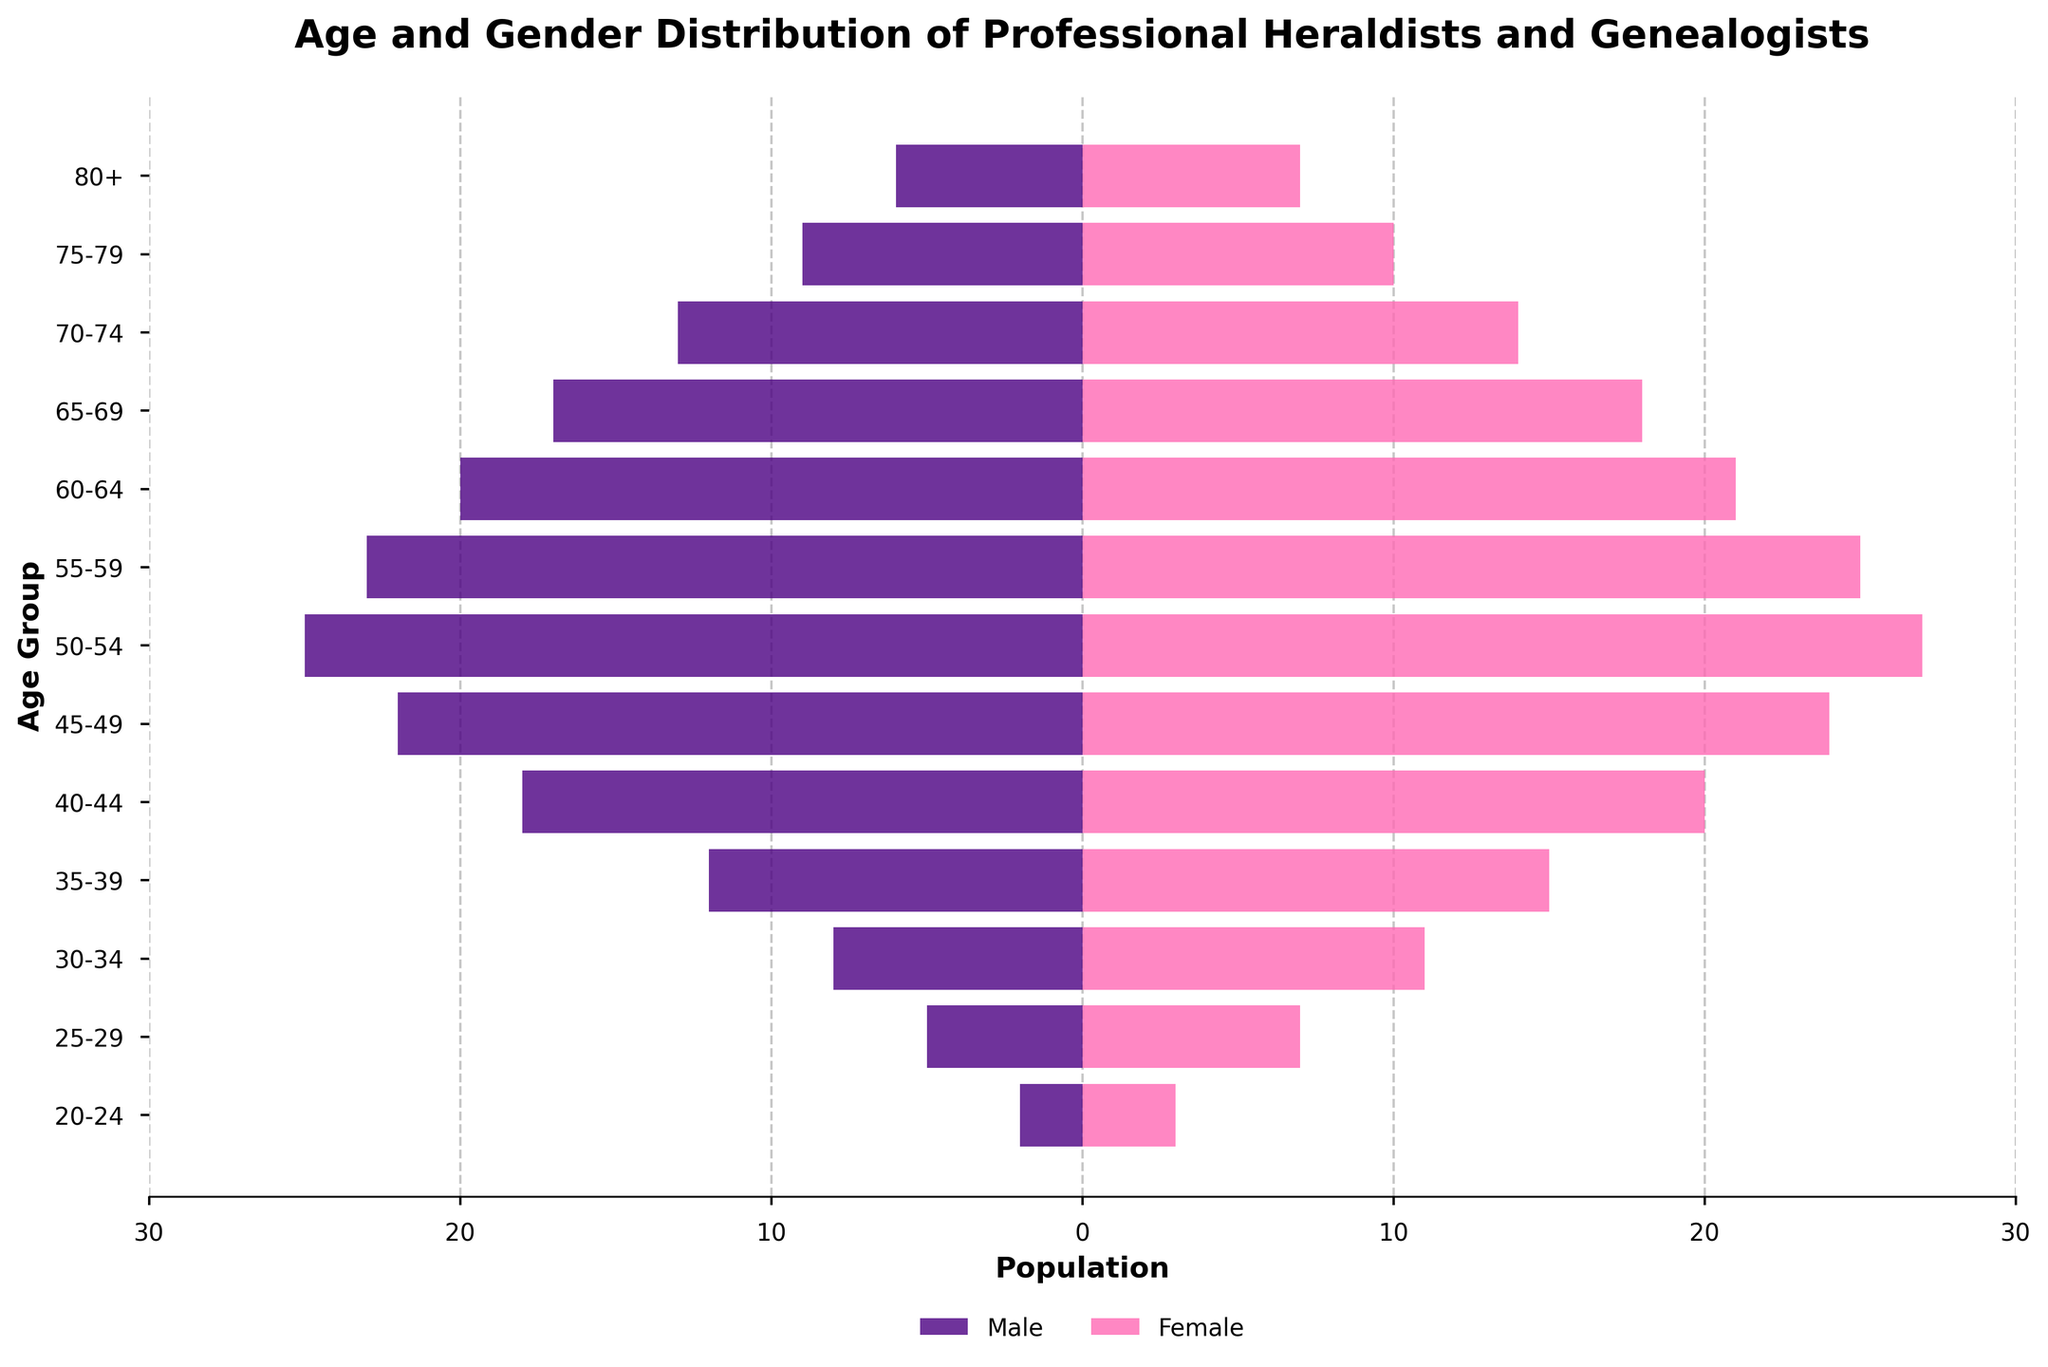What is the title of the figure? The title is found at the top of the figure and is used to describe what the figure represents. Here, it provides an overview of the subject of the distribution being shown.
Answer: Age and Gender Distribution of Professional Heraldists and Genealogists What are the colors used to represent males and females? The colors are distinct and help differentiate between the genders. Males are represented with a dark color, and females with a bright color.
Answer: Males: Indigo, Females: Pink Which age group has the highest total population of professional heraldists and genealogists? To find this, sum the counts for males and females in each age group and identify the highest. The calculation reveals that the 50-54 age group has the highest total of 52 (25 males + 27 females).
Answer: 50-54 What is the population of males in the 60-64 age group? Locate the 60-64 age group and read the value in the male bar. Here, it is negative, indicating the population size.
Answer: 20 In the 35-39 age group, who are more in number, males or females? Compare the values of males and females in the specified age group. The figures reveal there are 12 males and 15 females, so females are greater.
Answer: Females Calculate the average number of females across all age groups. Sum the values for females in each age group and divide by the total number of groups (13). The sum is 195, so the average is 195/13.
Answer: 15 Are there more females than males in the 25-29 age group? Compare the counts of males and females in this group. Males: 5, Females: 7.
Answer: Yes Which age group has equal numbers of males and females? Check each age group to see if the numbers for males and females are the same. In this case, no age group fits that criterion.
Answer: None Which gender has a high population in the 80+ age group? Compare populations in the 80+ age group. The figures are 6 males and 7 females. Females are slightly higher.
Answer: Females What is the total population of professional heraldists and genealogists in the 70-74 age group? Sum the male and female populations in the 70-74 age group. The sum is 13 males + 14 females = 27.
Answer: 27 